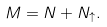<formula> <loc_0><loc_0><loc_500><loc_500>M = N + N _ { \uparrow } .</formula> 